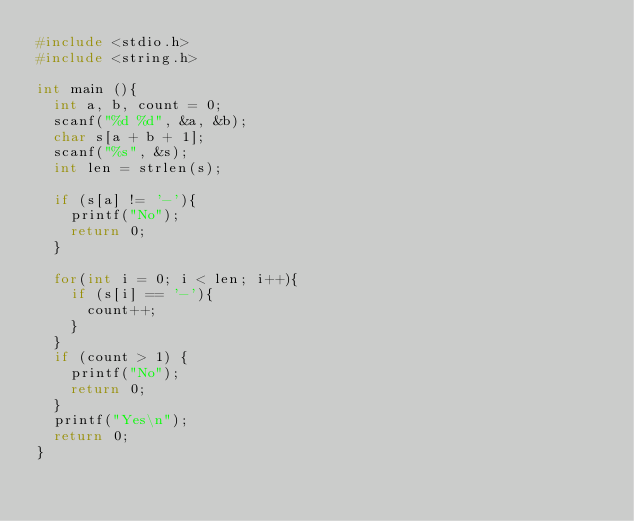Convert code to text. <code><loc_0><loc_0><loc_500><loc_500><_C_>#include <stdio.h>
#include <string.h>

int main (){
	int a, b, count = 0;
	scanf("%d %d", &a, &b);
	char s[a + b + 1];
	scanf("%s", &s);
	int len = strlen(s);
	
	if (s[a] != '-'){
		printf("No");
		return 0;
	}
	
	for(int i = 0; i < len; i++){
		if (s[i] == '-'){
			count++;
		}
	}
	if (count > 1) {
		printf("No");
		return 0;
	}
	printf("Yes\n");
	return 0;
}</code> 